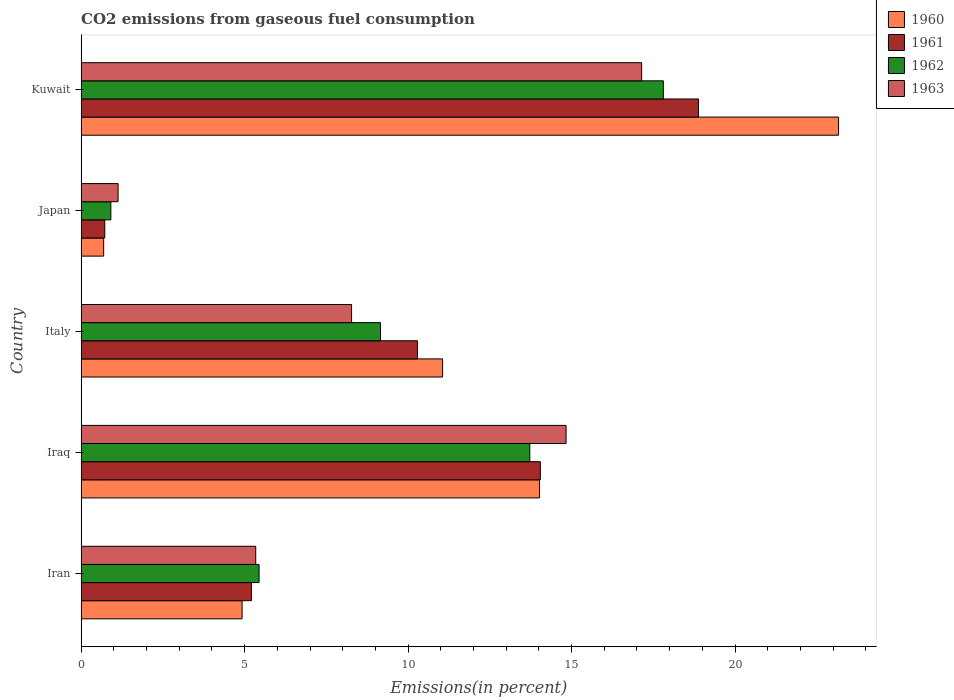How many different coloured bars are there?
Provide a succinct answer. 4. Are the number of bars on each tick of the Y-axis equal?
Provide a short and direct response. Yes. How many bars are there on the 5th tick from the top?
Offer a terse response. 4. How many bars are there on the 5th tick from the bottom?
Provide a short and direct response. 4. In how many cases, is the number of bars for a given country not equal to the number of legend labels?
Provide a short and direct response. 0. What is the total CO2 emitted in 1963 in Japan?
Ensure brevity in your answer.  1.13. Across all countries, what is the maximum total CO2 emitted in 1963?
Your answer should be very brief. 17.14. Across all countries, what is the minimum total CO2 emitted in 1960?
Provide a succinct answer. 0.69. In which country was the total CO2 emitted in 1960 maximum?
Your answer should be very brief. Kuwait. In which country was the total CO2 emitted in 1960 minimum?
Provide a succinct answer. Japan. What is the total total CO2 emitted in 1961 in the graph?
Ensure brevity in your answer.  49.15. What is the difference between the total CO2 emitted in 1960 in Italy and that in Japan?
Offer a very short reply. 10.37. What is the difference between the total CO2 emitted in 1961 in Japan and the total CO2 emitted in 1962 in Iran?
Give a very brief answer. -4.72. What is the average total CO2 emitted in 1963 per country?
Offer a terse response. 9.34. What is the difference between the total CO2 emitted in 1962 and total CO2 emitted in 1961 in Japan?
Give a very brief answer. 0.19. What is the ratio of the total CO2 emitted in 1963 in Iraq to that in Japan?
Offer a very short reply. 13.13. Is the total CO2 emitted in 1963 in Japan less than that in Kuwait?
Provide a succinct answer. Yes. Is the difference between the total CO2 emitted in 1962 in Iraq and Japan greater than the difference between the total CO2 emitted in 1961 in Iraq and Japan?
Your answer should be compact. No. What is the difference between the highest and the second highest total CO2 emitted in 1960?
Ensure brevity in your answer.  9.15. What is the difference between the highest and the lowest total CO2 emitted in 1961?
Your answer should be compact. 18.16. In how many countries, is the total CO2 emitted in 1961 greater than the average total CO2 emitted in 1961 taken over all countries?
Give a very brief answer. 3. What does the 1st bar from the bottom in Iran represents?
Keep it short and to the point. 1960. How many bars are there?
Provide a succinct answer. 20. Are all the bars in the graph horizontal?
Offer a very short reply. Yes. How many countries are there in the graph?
Your response must be concise. 5. What is the difference between two consecutive major ticks on the X-axis?
Ensure brevity in your answer.  5. Are the values on the major ticks of X-axis written in scientific E-notation?
Keep it short and to the point. No. Does the graph contain grids?
Give a very brief answer. No. Where does the legend appear in the graph?
Your answer should be compact. Top right. What is the title of the graph?
Give a very brief answer. CO2 emissions from gaseous fuel consumption. Does "1989" appear as one of the legend labels in the graph?
Provide a short and direct response. No. What is the label or title of the X-axis?
Your answer should be very brief. Emissions(in percent). What is the label or title of the Y-axis?
Give a very brief answer. Country. What is the Emissions(in percent) of 1960 in Iran?
Provide a short and direct response. 4.92. What is the Emissions(in percent) of 1961 in Iran?
Keep it short and to the point. 5.21. What is the Emissions(in percent) in 1962 in Iran?
Your answer should be compact. 5.44. What is the Emissions(in percent) in 1963 in Iran?
Your answer should be very brief. 5.34. What is the Emissions(in percent) in 1960 in Iraq?
Provide a short and direct response. 14.02. What is the Emissions(in percent) in 1961 in Iraq?
Ensure brevity in your answer.  14.05. What is the Emissions(in percent) in 1962 in Iraq?
Make the answer very short. 13.72. What is the Emissions(in percent) in 1963 in Iraq?
Provide a succinct answer. 14.83. What is the Emissions(in percent) in 1960 in Italy?
Offer a very short reply. 11.06. What is the Emissions(in percent) in 1961 in Italy?
Provide a short and direct response. 10.29. What is the Emissions(in percent) of 1962 in Italy?
Your answer should be compact. 9.16. What is the Emissions(in percent) of 1963 in Italy?
Offer a terse response. 8.27. What is the Emissions(in percent) in 1960 in Japan?
Offer a very short reply. 0.69. What is the Emissions(in percent) in 1961 in Japan?
Provide a succinct answer. 0.72. What is the Emissions(in percent) of 1962 in Japan?
Offer a very short reply. 0.91. What is the Emissions(in percent) in 1963 in Japan?
Your answer should be compact. 1.13. What is the Emissions(in percent) in 1960 in Kuwait?
Keep it short and to the point. 23.17. What is the Emissions(in percent) of 1961 in Kuwait?
Your answer should be very brief. 18.88. What is the Emissions(in percent) in 1962 in Kuwait?
Provide a succinct answer. 17.81. What is the Emissions(in percent) of 1963 in Kuwait?
Provide a short and direct response. 17.14. Across all countries, what is the maximum Emissions(in percent) in 1960?
Keep it short and to the point. 23.17. Across all countries, what is the maximum Emissions(in percent) in 1961?
Give a very brief answer. 18.88. Across all countries, what is the maximum Emissions(in percent) of 1962?
Keep it short and to the point. 17.81. Across all countries, what is the maximum Emissions(in percent) of 1963?
Ensure brevity in your answer.  17.14. Across all countries, what is the minimum Emissions(in percent) in 1960?
Provide a short and direct response. 0.69. Across all countries, what is the minimum Emissions(in percent) in 1961?
Offer a terse response. 0.72. Across all countries, what is the minimum Emissions(in percent) of 1962?
Your answer should be compact. 0.91. Across all countries, what is the minimum Emissions(in percent) in 1963?
Make the answer very short. 1.13. What is the total Emissions(in percent) in 1960 in the graph?
Provide a succinct answer. 53.85. What is the total Emissions(in percent) in 1961 in the graph?
Ensure brevity in your answer.  49.15. What is the total Emissions(in percent) of 1962 in the graph?
Your answer should be very brief. 47.04. What is the total Emissions(in percent) of 1963 in the graph?
Offer a terse response. 46.72. What is the difference between the Emissions(in percent) in 1960 in Iran and that in Iraq?
Your answer should be compact. -9.1. What is the difference between the Emissions(in percent) in 1961 in Iran and that in Iraq?
Your answer should be compact. -8.84. What is the difference between the Emissions(in percent) of 1962 in Iran and that in Iraq?
Ensure brevity in your answer.  -8.28. What is the difference between the Emissions(in percent) of 1963 in Iran and that in Iraq?
Provide a short and direct response. -9.49. What is the difference between the Emissions(in percent) in 1960 in Iran and that in Italy?
Provide a short and direct response. -6.13. What is the difference between the Emissions(in percent) of 1961 in Iran and that in Italy?
Your response must be concise. -5.08. What is the difference between the Emissions(in percent) of 1962 in Iran and that in Italy?
Offer a very short reply. -3.71. What is the difference between the Emissions(in percent) in 1963 in Iran and that in Italy?
Your answer should be compact. -2.93. What is the difference between the Emissions(in percent) in 1960 in Iran and that in Japan?
Ensure brevity in your answer.  4.23. What is the difference between the Emissions(in percent) in 1961 in Iran and that in Japan?
Your answer should be compact. 4.49. What is the difference between the Emissions(in percent) of 1962 in Iran and that in Japan?
Your response must be concise. 4.53. What is the difference between the Emissions(in percent) in 1963 in Iran and that in Japan?
Make the answer very short. 4.21. What is the difference between the Emissions(in percent) in 1960 in Iran and that in Kuwait?
Your answer should be very brief. -18.24. What is the difference between the Emissions(in percent) in 1961 in Iran and that in Kuwait?
Offer a very short reply. -13.67. What is the difference between the Emissions(in percent) in 1962 in Iran and that in Kuwait?
Keep it short and to the point. -12.37. What is the difference between the Emissions(in percent) of 1963 in Iran and that in Kuwait?
Provide a short and direct response. -11.8. What is the difference between the Emissions(in percent) in 1960 in Iraq and that in Italy?
Ensure brevity in your answer.  2.96. What is the difference between the Emissions(in percent) of 1961 in Iraq and that in Italy?
Your answer should be very brief. 3.76. What is the difference between the Emissions(in percent) of 1962 in Iraq and that in Italy?
Give a very brief answer. 4.57. What is the difference between the Emissions(in percent) of 1963 in Iraq and that in Italy?
Provide a succinct answer. 6.56. What is the difference between the Emissions(in percent) in 1960 in Iraq and that in Japan?
Keep it short and to the point. 13.33. What is the difference between the Emissions(in percent) in 1961 in Iraq and that in Japan?
Your response must be concise. 13.32. What is the difference between the Emissions(in percent) of 1962 in Iraq and that in Japan?
Give a very brief answer. 12.82. What is the difference between the Emissions(in percent) in 1963 in Iraq and that in Japan?
Your answer should be very brief. 13.7. What is the difference between the Emissions(in percent) in 1960 in Iraq and that in Kuwait?
Provide a short and direct response. -9.15. What is the difference between the Emissions(in percent) of 1961 in Iraq and that in Kuwait?
Your response must be concise. -4.84. What is the difference between the Emissions(in percent) of 1962 in Iraq and that in Kuwait?
Your answer should be compact. -4.09. What is the difference between the Emissions(in percent) in 1963 in Iraq and that in Kuwait?
Give a very brief answer. -2.31. What is the difference between the Emissions(in percent) in 1960 in Italy and that in Japan?
Make the answer very short. 10.37. What is the difference between the Emissions(in percent) in 1961 in Italy and that in Japan?
Ensure brevity in your answer.  9.56. What is the difference between the Emissions(in percent) of 1962 in Italy and that in Japan?
Provide a short and direct response. 8.25. What is the difference between the Emissions(in percent) in 1963 in Italy and that in Japan?
Your response must be concise. 7.14. What is the difference between the Emissions(in percent) of 1960 in Italy and that in Kuwait?
Offer a very short reply. -12.11. What is the difference between the Emissions(in percent) of 1961 in Italy and that in Kuwait?
Make the answer very short. -8.6. What is the difference between the Emissions(in percent) of 1962 in Italy and that in Kuwait?
Provide a short and direct response. -8.65. What is the difference between the Emissions(in percent) in 1963 in Italy and that in Kuwait?
Offer a very short reply. -8.87. What is the difference between the Emissions(in percent) in 1960 in Japan and that in Kuwait?
Keep it short and to the point. -22.48. What is the difference between the Emissions(in percent) of 1961 in Japan and that in Kuwait?
Give a very brief answer. -18.16. What is the difference between the Emissions(in percent) of 1962 in Japan and that in Kuwait?
Give a very brief answer. -16.9. What is the difference between the Emissions(in percent) in 1963 in Japan and that in Kuwait?
Offer a very short reply. -16.01. What is the difference between the Emissions(in percent) of 1960 in Iran and the Emissions(in percent) of 1961 in Iraq?
Ensure brevity in your answer.  -9.12. What is the difference between the Emissions(in percent) of 1960 in Iran and the Emissions(in percent) of 1962 in Iraq?
Keep it short and to the point. -8.8. What is the difference between the Emissions(in percent) of 1960 in Iran and the Emissions(in percent) of 1963 in Iraq?
Your response must be concise. -9.91. What is the difference between the Emissions(in percent) of 1961 in Iran and the Emissions(in percent) of 1962 in Iraq?
Keep it short and to the point. -8.51. What is the difference between the Emissions(in percent) in 1961 in Iran and the Emissions(in percent) in 1963 in Iraq?
Your answer should be very brief. -9.62. What is the difference between the Emissions(in percent) of 1962 in Iran and the Emissions(in percent) of 1963 in Iraq?
Make the answer very short. -9.39. What is the difference between the Emissions(in percent) in 1960 in Iran and the Emissions(in percent) in 1961 in Italy?
Provide a short and direct response. -5.36. What is the difference between the Emissions(in percent) of 1960 in Iran and the Emissions(in percent) of 1962 in Italy?
Ensure brevity in your answer.  -4.23. What is the difference between the Emissions(in percent) in 1960 in Iran and the Emissions(in percent) in 1963 in Italy?
Provide a short and direct response. -3.35. What is the difference between the Emissions(in percent) of 1961 in Iran and the Emissions(in percent) of 1962 in Italy?
Give a very brief answer. -3.95. What is the difference between the Emissions(in percent) of 1961 in Iran and the Emissions(in percent) of 1963 in Italy?
Give a very brief answer. -3.06. What is the difference between the Emissions(in percent) of 1962 in Iran and the Emissions(in percent) of 1963 in Italy?
Offer a terse response. -2.83. What is the difference between the Emissions(in percent) of 1960 in Iran and the Emissions(in percent) of 1961 in Japan?
Your response must be concise. 4.2. What is the difference between the Emissions(in percent) of 1960 in Iran and the Emissions(in percent) of 1962 in Japan?
Provide a short and direct response. 4.02. What is the difference between the Emissions(in percent) of 1960 in Iran and the Emissions(in percent) of 1963 in Japan?
Keep it short and to the point. 3.79. What is the difference between the Emissions(in percent) of 1961 in Iran and the Emissions(in percent) of 1962 in Japan?
Your response must be concise. 4.3. What is the difference between the Emissions(in percent) of 1961 in Iran and the Emissions(in percent) of 1963 in Japan?
Make the answer very short. 4.08. What is the difference between the Emissions(in percent) of 1962 in Iran and the Emissions(in percent) of 1963 in Japan?
Keep it short and to the point. 4.31. What is the difference between the Emissions(in percent) of 1960 in Iran and the Emissions(in percent) of 1961 in Kuwait?
Your response must be concise. -13.96. What is the difference between the Emissions(in percent) of 1960 in Iran and the Emissions(in percent) of 1962 in Kuwait?
Make the answer very short. -12.89. What is the difference between the Emissions(in percent) in 1960 in Iran and the Emissions(in percent) in 1963 in Kuwait?
Give a very brief answer. -12.22. What is the difference between the Emissions(in percent) in 1961 in Iran and the Emissions(in percent) in 1962 in Kuwait?
Make the answer very short. -12.6. What is the difference between the Emissions(in percent) of 1961 in Iran and the Emissions(in percent) of 1963 in Kuwait?
Keep it short and to the point. -11.94. What is the difference between the Emissions(in percent) of 1962 in Iran and the Emissions(in percent) of 1963 in Kuwait?
Your response must be concise. -11.7. What is the difference between the Emissions(in percent) in 1960 in Iraq and the Emissions(in percent) in 1961 in Italy?
Your answer should be very brief. 3.73. What is the difference between the Emissions(in percent) in 1960 in Iraq and the Emissions(in percent) in 1962 in Italy?
Ensure brevity in your answer.  4.86. What is the difference between the Emissions(in percent) of 1960 in Iraq and the Emissions(in percent) of 1963 in Italy?
Your response must be concise. 5.75. What is the difference between the Emissions(in percent) of 1961 in Iraq and the Emissions(in percent) of 1962 in Italy?
Provide a short and direct response. 4.89. What is the difference between the Emissions(in percent) of 1961 in Iraq and the Emissions(in percent) of 1963 in Italy?
Ensure brevity in your answer.  5.77. What is the difference between the Emissions(in percent) in 1962 in Iraq and the Emissions(in percent) in 1963 in Italy?
Your answer should be very brief. 5.45. What is the difference between the Emissions(in percent) in 1960 in Iraq and the Emissions(in percent) in 1961 in Japan?
Make the answer very short. 13.3. What is the difference between the Emissions(in percent) in 1960 in Iraq and the Emissions(in percent) in 1962 in Japan?
Your response must be concise. 13.11. What is the difference between the Emissions(in percent) in 1960 in Iraq and the Emissions(in percent) in 1963 in Japan?
Give a very brief answer. 12.89. What is the difference between the Emissions(in percent) in 1961 in Iraq and the Emissions(in percent) in 1962 in Japan?
Keep it short and to the point. 13.14. What is the difference between the Emissions(in percent) of 1961 in Iraq and the Emissions(in percent) of 1963 in Japan?
Ensure brevity in your answer.  12.92. What is the difference between the Emissions(in percent) of 1962 in Iraq and the Emissions(in percent) of 1963 in Japan?
Ensure brevity in your answer.  12.59. What is the difference between the Emissions(in percent) of 1960 in Iraq and the Emissions(in percent) of 1961 in Kuwait?
Ensure brevity in your answer.  -4.86. What is the difference between the Emissions(in percent) in 1960 in Iraq and the Emissions(in percent) in 1962 in Kuwait?
Offer a very short reply. -3.79. What is the difference between the Emissions(in percent) in 1960 in Iraq and the Emissions(in percent) in 1963 in Kuwait?
Keep it short and to the point. -3.12. What is the difference between the Emissions(in percent) in 1961 in Iraq and the Emissions(in percent) in 1962 in Kuwait?
Offer a terse response. -3.76. What is the difference between the Emissions(in percent) of 1961 in Iraq and the Emissions(in percent) of 1963 in Kuwait?
Your response must be concise. -3.1. What is the difference between the Emissions(in percent) in 1962 in Iraq and the Emissions(in percent) in 1963 in Kuwait?
Your response must be concise. -3.42. What is the difference between the Emissions(in percent) in 1960 in Italy and the Emissions(in percent) in 1961 in Japan?
Your answer should be very brief. 10.33. What is the difference between the Emissions(in percent) of 1960 in Italy and the Emissions(in percent) of 1962 in Japan?
Keep it short and to the point. 10.15. What is the difference between the Emissions(in percent) of 1960 in Italy and the Emissions(in percent) of 1963 in Japan?
Give a very brief answer. 9.93. What is the difference between the Emissions(in percent) of 1961 in Italy and the Emissions(in percent) of 1962 in Japan?
Your answer should be compact. 9.38. What is the difference between the Emissions(in percent) of 1961 in Italy and the Emissions(in percent) of 1963 in Japan?
Ensure brevity in your answer.  9.16. What is the difference between the Emissions(in percent) in 1962 in Italy and the Emissions(in percent) in 1963 in Japan?
Your answer should be very brief. 8.03. What is the difference between the Emissions(in percent) in 1960 in Italy and the Emissions(in percent) in 1961 in Kuwait?
Your response must be concise. -7.83. What is the difference between the Emissions(in percent) in 1960 in Italy and the Emissions(in percent) in 1962 in Kuwait?
Provide a succinct answer. -6.75. What is the difference between the Emissions(in percent) of 1960 in Italy and the Emissions(in percent) of 1963 in Kuwait?
Keep it short and to the point. -6.09. What is the difference between the Emissions(in percent) of 1961 in Italy and the Emissions(in percent) of 1962 in Kuwait?
Offer a very short reply. -7.52. What is the difference between the Emissions(in percent) of 1961 in Italy and the Emissions(in percent) of 1963 in Kuwait?
Provide a short and direct response. -6.86. What is the difference between the Emissions(in percent) of 1962 in Italy and the Emissions(in percent) of 1963 in Kuwait?
Offer a very short reply. -7.99. What is the difference between the Emissions(in percent) of 1960 in Japan and the Emissions(in percent) of 1961 in Kuwait?
Your answer should be very brief. -18.19. What is the difference between the Emissions(in percent) in 1960 in Japan and the Emissions(in percent) in 1962 in Kuwait?
Ensure brevity in your answer.  -17.12. What is the difference between the Emissions(in percent) of 1960 in Japan and the Emissions(in percent) of 1963 in Kuwait?
Make the answer very short. -16.46. What is the difference between the Emissions(in percent) of 1961 in Japan and the Emissions(in percent) of 1962 in Kuwait?
Offer a very short reply. -17.09. What is the difference between the Emissions(in percent) in 1961 in Japan and the Emissions(in percent) in 1963 in Kuwait?
Make the answer very short. -16.42. What is the difference between the Emissions(in percent) of 1962 in Japan and the Emissions(in percent) of 1963 in Kuwait?
Keep it short and to the point. -16.24. What is the average Emissions(in percent) in 1960 per country?
Offer a very short reply. 10.77. What is the average Emissions(in percent) in 1961 per country?
Give a very brief answer. 9.83. What is the average Emissions(in percent) in 1962 per country?
Your answer should be very brief. 9.41. What is the average Emissions(in percent) in 1963 per country?
Give a very brief answer. 9.34. What is the difference between the Emissions(in percent) in 1960 and Emissions(in percent) in 1961 in Iran?
Offer a very short reply. -0.29. What is the difference between the Emissions(in percent) of 1960 and Emissions(in percent) of 1962 in Iran?
Provide a succinct answer. -0.52. What is the difference between the Emissions(in percent) of 1960 and Emissions(in percent) of 1963 in Iran?
Keep it short and to the point. -0.42. What is the difference between the Emissions(in percent) of 1961 and Emissions(in percent) of 1962 in Iran?
Provide a succinct answer. -0.23. What is the difference between the Emissions(in percent) of 1961 and Emissions(in percent) of 1963 in Iran?
Ensure brevity in your answer.  -0.13. What is the difference between the Emissions(in percent) of 1962 and Emissions(in percent) of 1963 in Iran?
Give a very brief answer. 0.1. What is the difference between the Emissions(in percent) in 1960 and Emissions(in percent) in 1961 in Iraq?
Provide a succinct answer. -0.03. What is the difference between the Emissions(in percent) of 1960 and Emissions(in percent) of 1962 in Iraq?
Provide a short and direct response. 0.3. What is the difference between the Emissions(in percent) of 1960 and Emissions(in percent) of 1963 in Iraq?
Provide a short and direct response. -0.81. What is the difference between the Emissions(in percent) of 1961 and Emissions(in percent) of 1962 in Iraq?
Your response must be concise. 0.32. What is the difference between the Emissions(in percent) in 1961 and Emissions(in percent) in 1963 in Iraq?
Offer a very short reply. -0.79. What is the difference between the Emissions(in percent) of 1962 and Emissions(in percent) of 1963 in Iraq?
Ensure brevity in your answer.  -1.11. What is the difference between the Emissions(in percent) of 1960 and Emissions(in percent) of 1961 in Italy?
Offer a terse response. 0.77. What is the difference between the Emissions(in percent) in 1960 and Emissions(in percent) in 1962 in Italy?
Your response must be concise. 1.9. What is the difference between the Emissions(in percent) of 1960 and Emissions(in percent) of 1963 in Italy?
Make the answer very short. 2.78. What is the difference between the Emissions(in percent) of 1961 and Emissions(in percent) of 1962 in Italy?
Provide a succinct answer. 1.13. What is the difference between the Emissions(in percent) of 1961 and Emissions(in percent) of 1963 in Italy?
Give a very brief answer. 2.02. What is the difference between the Emissions(in percent) in 1962 and Emissions(in percent) in 1963 in Italy?
Give a very brief answer. 0.88. What is the difference between the Emissions(in percent) in 1960 and Emissions(in percent) in 1961 in Japan?
Provide a succinct answer. -0.03. What is the difference between the Emissions(in percent) in 1960 and Emissions(in percent) in 1962 in Japan?
Make the answer very short. -0.22. What is the difference between the Emissions(in percent) in 1960 and Emissions(in percent) in 1963 in Japan?
Keep it short and to the point. -0.44. What is the difference between the Emissions(in percent) in 1961 and Emissions(in percent) in 1962 in Japan?
Give a very brief answer. -0.19. What is the difference between the Emissions(in percent) in 1961 and Emissions(in percent) in 1963 in Japan?
Your answer should be compact. -0.41. What is the difference between the Emissions(in percent) of 1962 and Emissions(in percent) of 1963 in Japan?
Give a very brief answer. -0.22. What is the difference between the Emissions(in percent) in 1960 and Emissions(in percent) in 1961 in Kuwait?
Offer a very short reply. 4.28. What is the difference between the Emissions(in percent) in 1960 and Emissions(in percent) in 1962 in Kuwait?
Your response must be concise. 5.36. What is the difference between the Emissions(in percent) in 1960 and Emissions(in percent) in 1963 in Kuwait?
Provide a succinct answer. 6.02. What is the difference between the Emissions(in percent) of 1961 and Emissions(in percent) of 1962 in Kuwait?
Make the answer very short. 1.07. What is the difference between the Emissions(in percent) in 1961 and Emissions(in percent) in 1963 in Kuwait?
Provide a succinct answer. 1.74. What is the difference between the Emissions(in percent) in 1962 and Emissions(in percent) in 1963 in Kuwait?
Your response must be concise. 0.66. What is the ratio of the Emissions(in percent) in 1960 in Iran to that in Iraq?
Give a very brief answer. 0.35. What is the ratio of the Emissions(in percent) of 1961 in Iran to that in Iraq?
Provide a succinct answer. 0.37. What is the ratio of the Emissions(in percent) of 1962 in Iran to that in Iraq?
Ensure brevity in your answer.  0.4. What is the ratio of the Emissions(in percent) in 1963 in Iran to that in Iraq?
Give a very brief answer. 0.36. What is the ratio of the Emissions(in percent) in 1960 in Iran to that in Italy?
Provide a short and direct response. 0.45. What is the ratio of the Emissions(in percent) of 1961 in Iran to that in Italy?
Your answer should be compact. 0.51. What is the ratio of the Emissions(in percent) in 1962 in Iran to that in Italy?
Keep it short and to the point. 0.59. What is the ratio of the Emissions(in percent) of 1963 in Iran to that in Italy?
Your response must be concise. 0.65. What is the ratio of the Emissions(in percent) in 1960 in Iran to that in Japan?
Your answer should be compact. 7.15. What is the ratio of the Emissions(in percent) in 1961 in Iran to that in Japan?
Offer a terse response. 7.21. What is the ratio of the Emissions(in percent) of 1962 in Iran to that in Japan?
Ensure brevity in your answer.  5.99. What is the ratio of the Emissions(in percent) of 1963 in Iran to that in Japan?
Give a very brief answer. 4.73. What is the ratio of the Emissions(in percent) in 1960 in Iran to that in Kuwait?
Your response must be concise. 0.21. What is the ratio of the Emissions(in percent) in 1961 in Iran to that in Kuwait?
Provide a succinct answer. 0.28. What is the ratio of the Emissions(in percent) in 1962 in Iran to that in Kuwait?
Give a very brief answer. 0.31. What is the ratio of the Emissions(in percent) in 1963 in Iran to that in Kuwait?
Offer a very short reply. 0.31. What is the ratio of the Emissions(in percent) in 1960 in Iraq to that in Italy?
Offer a terse response. 1.27. What is the ratio of the Emissions(in percent) in 1961 in Iraq to that in Italy?
Keep it short and to the point. 1.37. What is the ratio of the Emissions(in percent) of 1962 in Iraq to that in Italy?
Provide a short and direct response. 1.5. What is the ratio of the Emissions(in percent) of 1963 in Iraq to that in Italy?
Keep it short and to the point. 1.79. What is the ratio of the Emissions(in percent) in 1960 in Iraq to that in Japan?
Keep it short and to the point. 20.37. What is the ratio of the Emissions(in percent) of 1961 in Iraq to that in Japan?
Keep it short and to the point. 19.43. What is the ratio of the Emissions(in percent) in 1962 in Iraq to that in Japan?
Keep it short and to the point. 15.11. What is the ratio of the Emissions(in percent) of 1963 in Iraq to that in Japan?
Ensure brevity in your answer.  13.13. What is the ratio of the Emissions(in percent) of 1960 in Iraq to that in Kuwait?
Your response must be concise. 0.61. What is the ratio of the Emissions(in percent) of 1961 in Iraq to that in Kuwait?
Your answer should be very brief. 0.74. What is the ratio of the Emissions(in percent) of 1962 in Iraq to that in Kuwait?
Offer a terse response. 0.77. What is the ratio of the Emissions(in percent) of 1963 in Iraq to that in Kuwait?
Make the answer very short. 0.87. What is the ratio of the Emissions(in percent) in 1960 in Italy to that in Japan?
Provide a succinct answer. 16.06. What is the ratio of the Emissions(in percent) of 1961 in Italy to that in Japan?
Offer a very short reply. 14.23. What is the ratio of the Emissions(in percent) of 1962 in Italy to that in Japan?
Make the answer very short. 10.09. What is the ratio of the Emissions(in percent) of 1963 in Italy to that in Japan?
Your answer should be compact. 7.32. What is the ratio of the Emissions(in percent) in 1960 in Italy to that in Kuwait?
Offer a terse response. 0.48. What is the ratio of the Emissions(in percent) in 1961 in Italy to that in Kuwait?
Offer a very short reply. 0.54. What is the ratio of the Emissions(in percent) in 1962 in Italy to that in Kuwait?
Offer a very short reply. 0.51. What is the ratio of the Emissions(in percent) of 1963 in Italy to that in Kuwait?
Offer a terse response. 0.48. What is the ratio of the Emissions(in percent) in 1960 in Japan to that in Kuwait?
Provide a succinct answer. 0.03. What is the ratio of the Emissions(in percent) in 1961 in Japan to that in Kuwait?
Your answer should be very brief. 0.04. What is the ratio of the Emissions(in percent) in 1962 in Japan to that in Kuwait?
Give a very brief answer. 0.05. What is the ratio of the Emissions(in percent) of 1963 in Japan to that in Kuwait?
Keep it short and to the point. 0.07. What is the difference between the highest and the second highest Emissions(in percent) of 1960?
Your response must be concise. 9.15. What is the difference between the highest and the second highest Emissions(in percent) of 1961?
Your answer should be compact. 4.84. What is the difference between the highest and the second highest Emissions(in percent) in 1962?
Give a very brief answer. 4.09. What is the difference between the highest and the second highest Emissions(in percent) of 1963?
Ensure brevity in your answer.  2.31. What is the difference between the highest and the lowest Emissions(in percent) in 1960?
Your answer should be very brief. 22.48. What is the difference between the highest and the lowest Emissions(in percent) of 1961?
Your response must be concise. 18.16. What is the difference between the highest and the lowest Emissions(in percent) in 1962?
Your answer should be compact. 16.9. What is the difference between the highest and the lowest Emissions(in percent) of 1963?
Offer a very short reply. 16.01. 